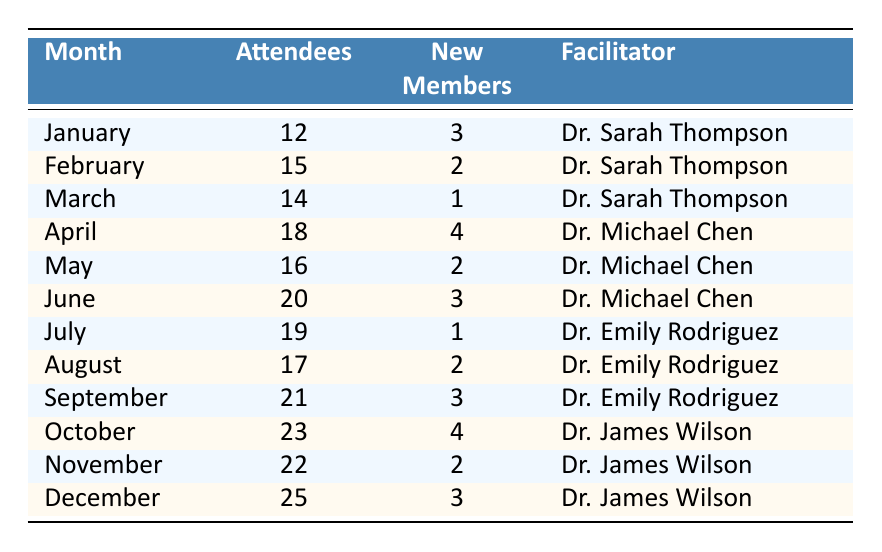What was the highest attendance in the grief support group? The row corresponding to the highest attendance can be found by scanning the "Attendees" column. December has the maximum value of 25.
Answer: 25 Which month had the most new members? By evaluating the "New Members" column, April shows the highest value of 4, indicating it had the most new members.
Answer: April How many total attendees were there throughout the year? Adding the number of attendees for each month gives us a total of: 12 + 15 + 14 + 18 + 16 + 20 + 19 + 17 + 21 + 23 + 22 + 25 =  252.
Answer: 252 Did Dr. Emily Rodriguez facilitate any meetings in the first half of the year? Reviewing the "Facilitator" column, Dr. Emily Rodriguez facilitated meetings in July and August, which are in the second half of the year. Therefore, she did not facilitate any meetings in the first half.
Answer: No What is the average number of new members per month? To find the average, sum all new members: 3 + 2 + 1 + 4 + 2 + 3 + 1 + 2 + 3 + 4 + 2 + 3 = 32. There are 12 months, so the average is 32/12, which equals approximately 2.67.
Answer: 2.67 Which facilitator had the highest number of attendees on average? Calculate the average for each facilitator: Dr. Sarah Thompson (12 + 15 + 14) / 3 = 13.67, Dr. Michael Chen (18 + 16 + 20) / 3 = 18. The averages for Dr. Emily Rodriguez (19 + 17 + 21) / 3 = 19, and Dr. James Wilson (23 + 22 + 25) / 3 = 23. The highest average is 23 for Dr. James Wilson.
Answer: Dr. James Wilson Did attendance increase every month? Examining the "Attendees" column month by month shows that, while there are increases from time to time, attendance decreased in February, March, and August.
Answer: No How many months had more than 20 attendees? By checking the "Attendees" column, the months with more than 20 attendees are: October (23), November (22), and December (25). Therefore, there are 3 months with more than 20 attendees.
Answer: 3 